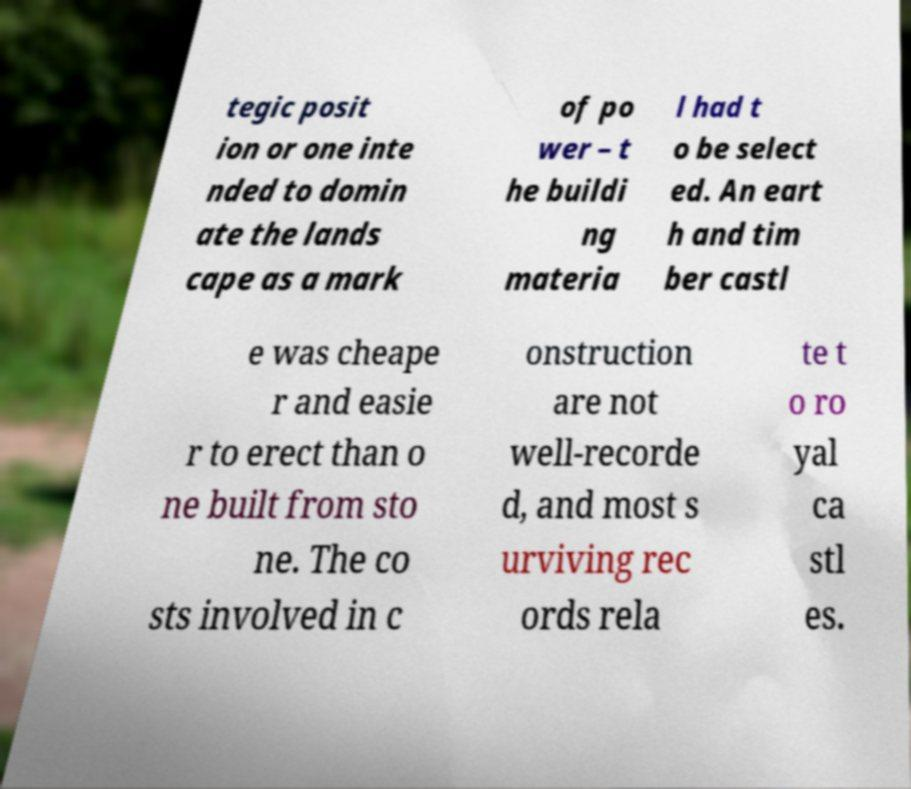There's text embedded in this image that I need extracted. Can you transcribe it verbatim? tegic posit ion or one inte nded to domin ate the lands cape as a mark of po wer – t he buildi ng materia l had t o be select ed. An eart h and tim ber castl e was cheape r and easie r to erect than o ne built from sto ne. The co sts involved in c onstruction are not well-recorde d, and most s urviving rec ords rela te t o ro yal ca stl es. 